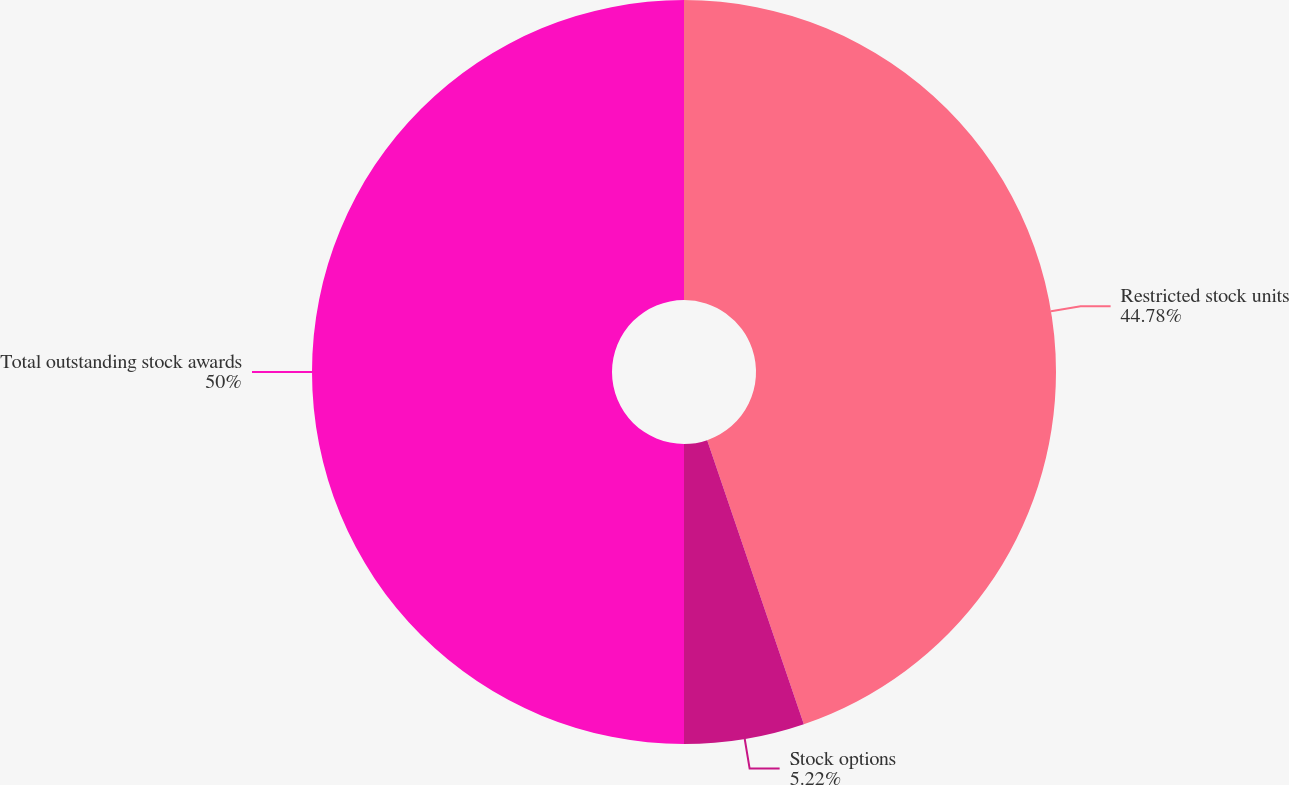Convert chart to OTSL. <chart><loc_0><loc_0><loc_500><loc_500><pie_chart><fcel>Restricted stock units<fcel>Stock options<fcel>Total outstanding stock awards<nl><fcel>44.78%<fcel>5.22%<fcel>50.0%<nl></chart> 